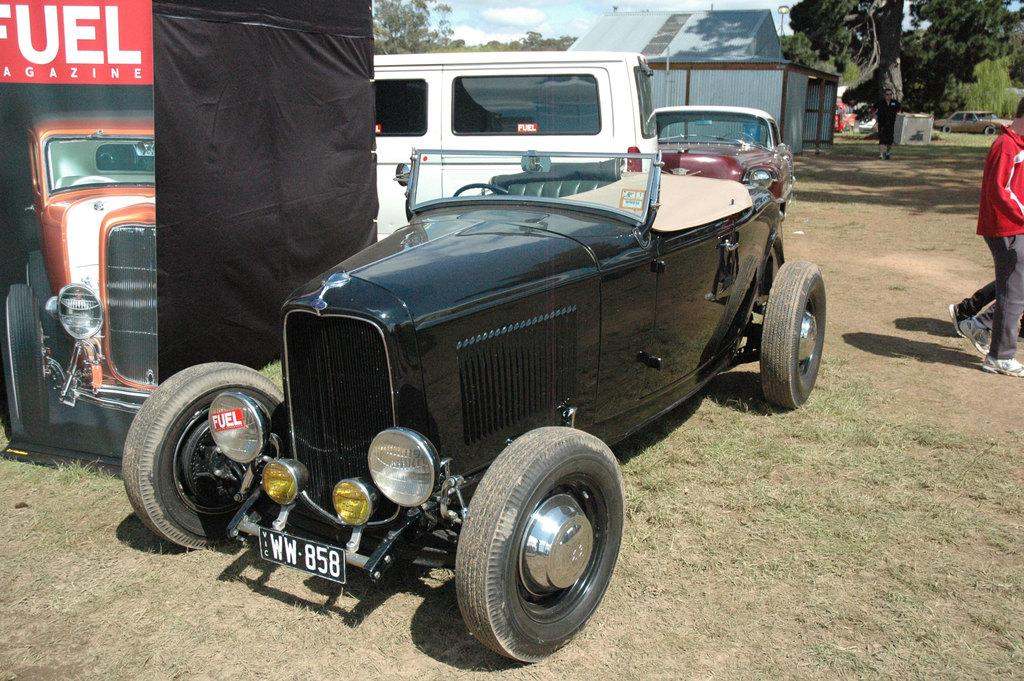What types of objects can be seen in the image? There are vehicles, people, a house, trees, and other objects on the ground visible in the image. Can you describe the setting of the image? The image features a grassy area with trees and a house in the background. What is visible in the sky in the image? The sky is visible in the background of the image. How does the flesh of the idea begin to take shape in the image? There is no flesh or idea present in the image; it features vehicles, people, a house, trees, and other objects on the ground. 